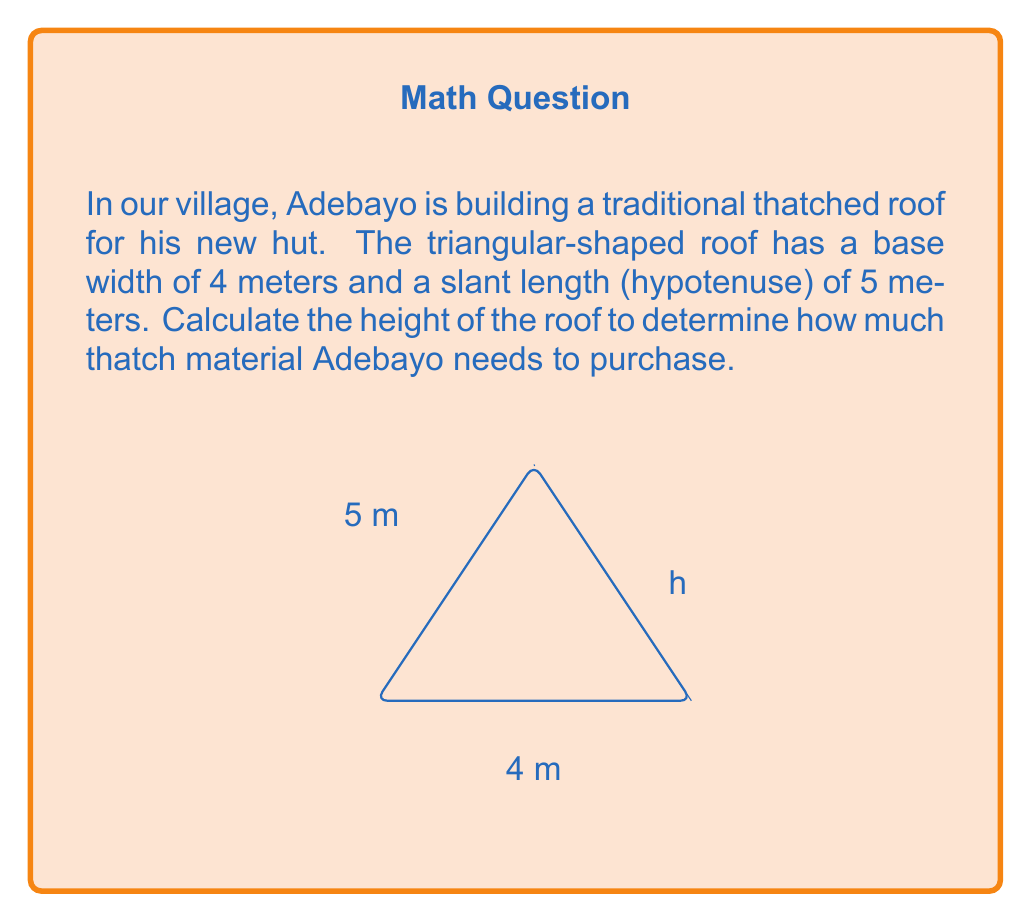Teach me how to tackle this problem. Let's approach this step-by-step using the Pythagorean theorem:

1) In a right-angled triangle, the Pythagorean theorem states that:
   $a^2 + b^2 = c^2$
   where $c$ is the hypotenuse, and $a$ and $b$ are the other two sides.

2) In our case:
   - The base (width) is 4 meters
   - The hypotenuse is 5 meters
   - The height is what we're solving for, let's call it $h$

3) Half of the base forms the bottom of our right-angled triangle:
   $\frac{4}{2} = 2$ meters

4) Now we can set up our equation:
   $2^2 + h^2 = 5^2$

5) Simplify:
   $4 + h^2 = 25$

6) Subtract 4 from both sides:
   $h^2 = 21$

7) Take the square root of both sides:
   $h = \sqrt{21}$

8) Simplify:
   $h = \sqrt{21} \approx 4.58$ meters

Therefore, the height of the roof is approximately 4.58 meters.
Answer: $\sqrt{21}$ meters or approximately 4.58 meters 